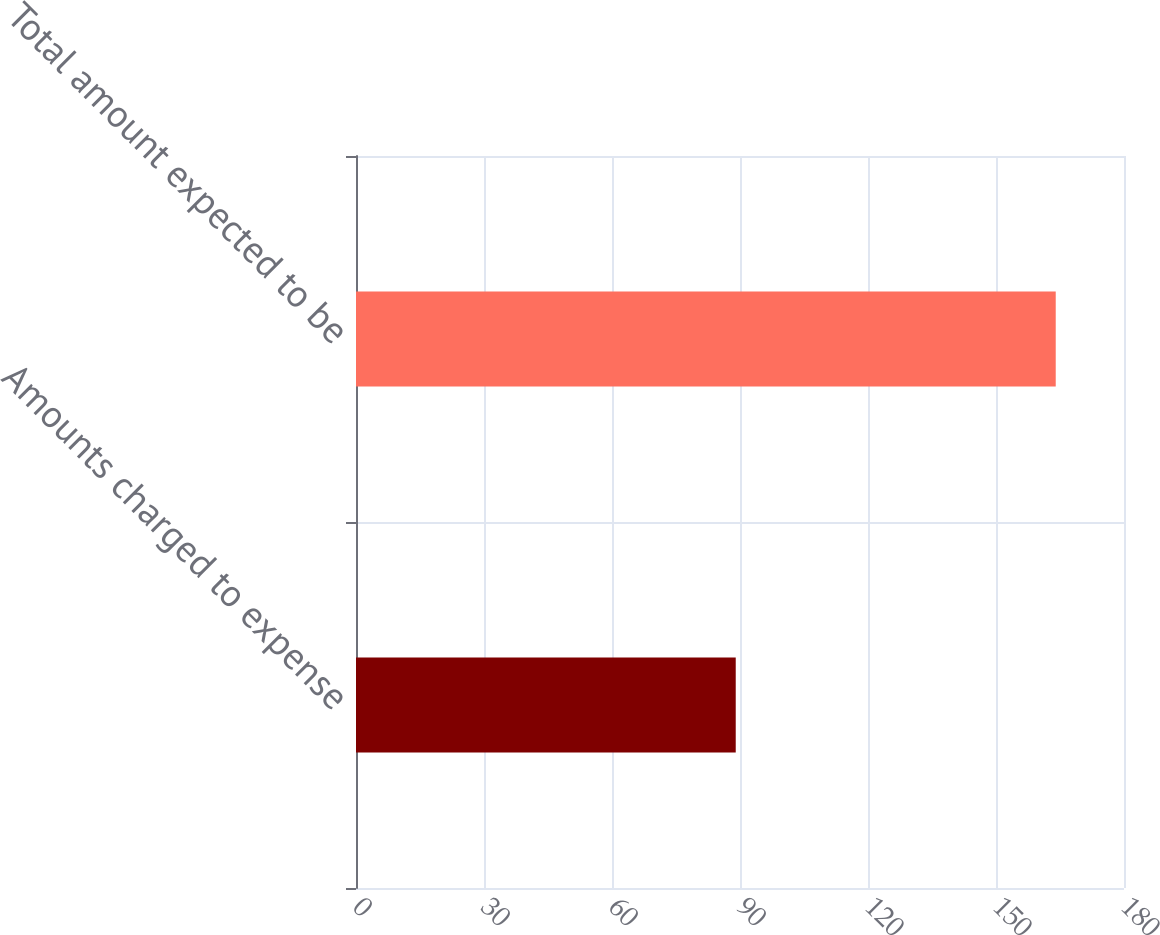Convert chart. <chart><loc_0><loc_0><loc_500><loc_500><bar_chart><fcel>Amounts charged to expense<fcel>Total amount expected to be<nl><fcel>89<fcel>164<nl></chart> 